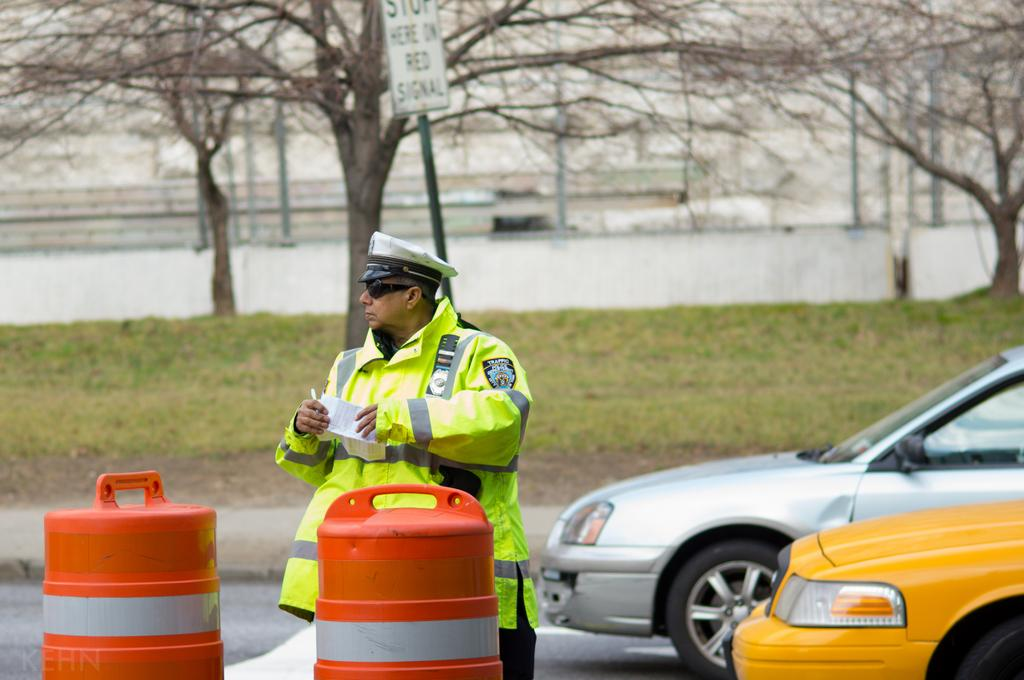<image>
Summarize the visual content of the image. A man who works for the traffic police department looks to be writing a ticket. 